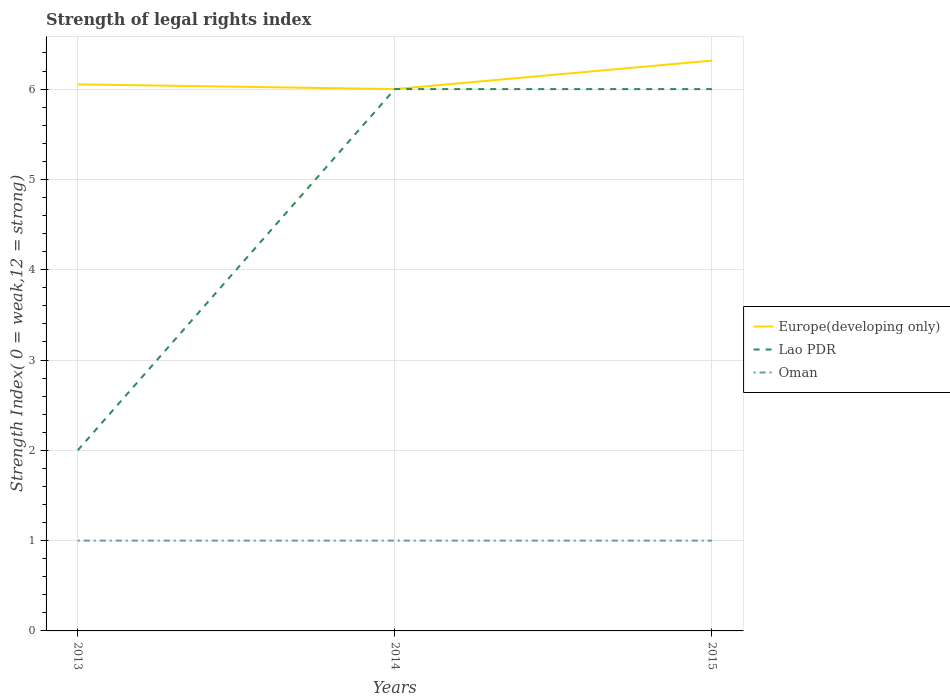Across all years, what is the maximum strength index in Europe(developing only)?
Make the answer very short. 6. What is the difference between the highest and the second highest strength index in Oman?
Keep it short and to the point. 0. How many lines are there?
Keep it short and to the point. 3. What is the difference between two consecutive major ticks on the Y-axis?
Your answer should be compact. 1. Are the values on the major ticks of Y-axis written in scientific E-notation?
Provide a short and direct response. No. Does the graph contain any zero values?
Provide a short and direct response. No. Where does the legend appear in the graph?
Offer a very short reply. Center right. How are the legend labels stacked?
Make the answer very short. Vertical. What is the title of the graph?
Give a very brief answer. Strength of legal rights index. What is the label or title of the X-axis?
Your response must be concise. Years. What is the label or title of the Y-axis?
Provide a short and direct response. Strength Index( 0 = weak,12 = strong). What is the Strength Index( 0 = weak,12 = strong) in Europe(developing only) in 2013?
Ensure brevity in your answer.  6.05. What is the Strength Index( 0 = weak,12 = strong) of Oman in 2013?
Your answer should be very brief. 1. What is the Strength Index( 0 = weak,12 = strong) in Lao PDR in 2014?
Provide a succinct answer. 6. What is the Strength Index( 0 = weak,12 = strong) of Oman in 2014?
Provide a short and direct response. 1. What is the Strength Index( 0 = weak,12 = strong) in Europe(developing only) in 2015?
Your response must be concise. 6.32. Across all years, what is the maximum Strength Index( 0 = weak,12 = strong) in Europe(developing only)?
Provide a succinct answer. 6.32. Across all years, what is the maximum Strength Index( 0 = weak,12 = strong) of Lao PDR?
Offer a very short reply. 6. Across all years, what is the maximum Strength Index( 0 = weak,12 = strong) of Oman?
Provide a succinct answer. 1. What is the total Strength Index( 0 = weak,12 = strong) of Europe(developing only) in the graph?
Give a very brief answer. 18.37. What is the difference between the Strength Index( 0 = weak,12 = strong) in Europe(developing only) in 2013 and that in 2014?
Keep it short and to the point. 0.05. What is the difference between the Strength Index( 0 = weak,12 = strong) of Oman in 2013 and that in 2014?
Provide a short and direct response. 0. What is the difference between the Strength Index( 0 = weak,12 = strong) in Europe(developing only) in 2013 and that in 2015?
Give a very brief answer. -0.26. What is the difference between the Strength Index( 0 = weak,12 = strong) of Europe(developing only) in 2014 and that in 2015?
Make the answer very short. -0.32. What is the difference between the Strength Index( 0 = weak,12 = strong) in Oman in 2014 and that in 2015?
Provide a succinct answer. 0. What is the difference between the Strength Index( 0 = weak,12 = strong) of Europe(developing only) in 2013 and the Strength Index( 0 = weak,12 = strong) of Lao PDR in 2014?
Your answer should be compact. 0.05. What is the difference between the Strength Index( 0 = weak,12 = strong) in Europe(developing only) in 2013 and the Strength Index( 0 = weak,12 = strong) in Oman in 2014?
Keep it short and to the point. 5.05. What is the difference between the Strength Index( 0 = weak,12 = strong) of Europe(developing only) in 2013 and the Strength Index( 0 = weak,12 = strong) of Lao PDR in 2015?
Give a very brief answer. 0.05. What is the difference between the Strength Index( 0 = weak,12 = strong) in Europe(developing only) in 2013 and the Strength Index( 0 = weak,12 = strong) in Oman in 2015?
Offer a very short reply. 5.05. What is the average Strength Index( 0 = weak,12 = strong) in Europe(developing only) per year?
Offer a very short reply. 6.12. What is the average Strength Index( 0 = weak,12 = strong) in Lao PDR per year?
Make the answer very short. 4.67. What is the average Strength Index( 0 = weak,12 = strong) of Oman per year?
Your response must be concise. 1. In the year 2013, what is the difference between the Strength Index( 0 = weak,12 = strong) in Europe(developing only) and Strength Index( 0 = weak,12 = strong) in Lao PDR?
Provide a short and direct response. 4.05. In the year 2013, what is the difference between the Strength Index( 0 = weak,12 = strong) of Europe(developing only) and Strength Index( 0 = weak,12 = strong) of Oman?
Ensure brevity in your answer.  5.05. In the year 2013, what is the difference between the Strength Index( 0 = weak,12 = strong) of Lao PDR and Strength Index( 0 = weak,12 = strong) of Oman?
Keep it short and to the point. 1. In the year 2015, what is the difference between the Strength Index( 0 = weak,12 = strong) of Europe(developing only) and Strength Index( 0 = weak,12 = strong) of Lao PDR?
Provide a succinct answer. 0.32. In the year 2015, what is the difference between the Strength Index( 0 = weak,12 = strong) of Europe(developing only) and Strength Index( 0 = weak,12 = strong) of Oman?
Make the answer very short. 5.32. In the year 2015, what is the difference between the Strength Index( 0 = weak,12 = strong) in Lao PDR and Strength Index( 0 = weak,12 = strong) in Oman?
Give a very brief answer. 5. What is the ratio of the Strength Index( 0 = weak,12 = strong) of Europe(developing only) in 2013 to that in 2014?
Offer a very short reply. 1.01. What is the ratio of the Strength Index( 0 = weak,12 = strong) in Lao PDR in 2013 to that in 2014?
Make the answer very short. 0.33. What is the ratio of the Strength Index( 0 = weak,12 = strong) in Oman in 2013 to that in 2015?
Your response must be concise. 1. What is the ratio of the Strength Index( 0 = weak,12 = strong) in Lao PDR in 2014 to that in 2015?
Offer a terse response. 1. What is the ratio of the Strength Index( 0 = weak,12 = strong) of Oman in 2014 to that in 2015?
Provide a succinct answer. 1. What is the difference between the highest and the second highest Strength Index( 0 = weak,12 = strong) of Europe(developing only)?
Your response must be concise. 0.26. What is the difference between the highest and the lowest Strength Index( 0 = weak,12 = strong) of Europe(developing only)?
Your response must be concise. 0.32. What is the difference between the highest and the lowest Strength Index( 0 = weak,12 = strong) of Oman?
Provide a succinct answer. 0. 